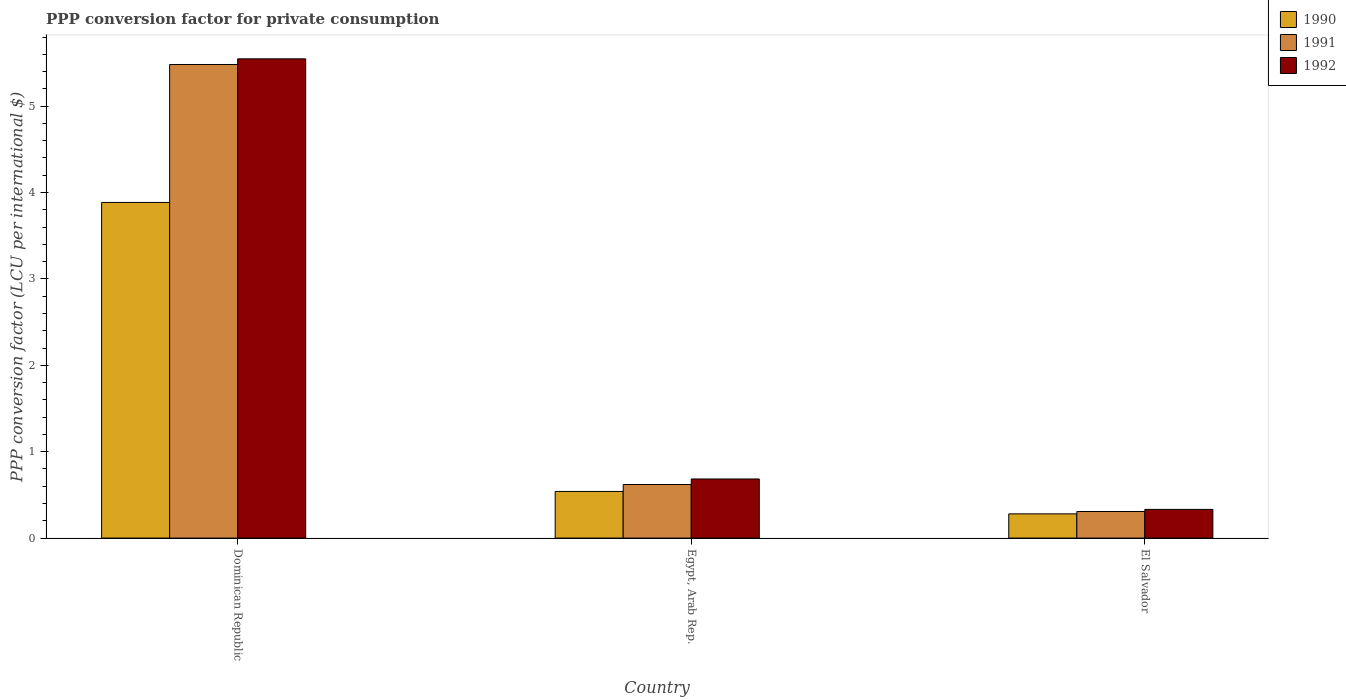How many different coloured bars are there?
Make the answer very short. 3. Are the number of bars on each tick of the X-axis equal?
Ensure brevity in your answer.  Yes. How many bars are there on the 1st tick from the left?
Keep it short and to the point. 3. What is the label of the 1st group of bars from the left?
Give a very brief answer. Dominican Republic. In how many cases, is the number of bars for a given country not equal to the number of legend labels?
Give a very brief answer. 0. What is the PPP conversion factor for private consumption in 1992 in El Salvador?
Offer a very short reply. 0.33. Across all countries, what is the maximum PPP conversion factor for private consumption in 1991?
Make the answer very short. 5.48. Across all countries, what is the minimum PPP conversion factor for private consumption in 1991?
Your answer should be compact. 0.31. In which country was the PPP conversion factor for private consumption in 1990 maximum?
Keep it short and to the point. Dominican Republic. In which country was the PPP conversion factor for private consumption in 1991 minimum?
Provide a succinct answer. El Salvador. What is the total PPP conversion factor for private consumption in 1991 in the graph?
Keep it short and to the point. 6.41. What is the difference between the PPP conversion factor for private consumption in 1991 in Dominican Republic and that in El Salvador?
Provide a succinct answer. 5.17. What is the difference between the PPP conversion factor for private consumption in 1991 in El Salvador and the PPP conversion factor for private consumption in 1992 in Dominican Republic?
Give a very brief answer. -5.24. What is the average PPP conversion factor for private consumption in 1990 per country?
Provide a succinct answer. 1.57. What is the difference between the PPP conversion factor for private consumption of/in 1992 and PPP conversion factor for private consumption of/in 1991 in Egypt, Arab Rep.?
Your answer should be compact. 0.06. In how many countries, is the PPP conversion factor for private consumption in 1992 greater than 3.8 LCU?
Offer a very short reply. 1. What is the ratio of the PPP conversion factor for private consumption in 1990 in Dominican Republic to that in Egypt, Arab Rep.?
Keep it short and to the point. 7.19. What is the difference between the highest and the second highest PPP conversion factor for private consumption in 1992?
Keep it short and to the point. 0.35. What is the difference between the highest and the lowest PPP conversion factor for private consumption in 1990?
Ensure brevity in your answer.  3.6. In how many countries, is the PPP conversion factor for private consumption in 1991 greater than the average PPP conversion factor for private consumption in 1991 taken over all countries?
Make the answer very short. 1. Is the sum of the PPP conversion factor for private consumption in 1992 in Egypt, Arab Rep. and El Salvador greater than the maximum PPP conversion factor for private consumption in 1991 across all countries?
Offer a very short reply. No. What does the 2nd bar from the left in Egypt, Arab Rep. represents?
Your answer should be very brief. 1991. How many bars are there?
Your answer should be very brief. 9. How many countries are there in the graph?
Provide a short and direct response. 3. Are the values on the major ticks of Y-axis written in scientific E-notation?
Make the answer very short. No. Does the graph contain any zero values?
Your answer should be compact. No. Where does the legend appear in the graph?
Make the answer very short. Top right. How many legend labels are there?
Keep it short and to the point. 3. What is the title of the graph?
Your answer should be compact. PPP conversion factor for private consumption. Does "2005" appear as one of the legend labels in the graph?
Your answer should be compact. No. What is the label or title of the X-axis?
Provide a short and direct response. Country. What is the label or title of the Y-axis?
Your answer should be compact. PPP conversion factor (LCU per international $). What is the PPP conversion factor (LCU per international $) in 1990 in Dominican Republic?
Make the answer very short. 3.89. What is the PPP conversion factor (LCU per international $) in 1991 in Dominican Republic?
Provide a succinct answer. 5.48. What is the PPP conversion factor (LCU per international $) of 1992 in Dominican Republic?
Your answer should be compact. 5.55. What is the PPP conversion factor (LCU per international $) in 1990 in Egypt, Arab Rep.?
Your response must be concise. 0.54. What is the PPP conversion factor (LCU per international $) of 1991 in Egypt, Arab Rep.?
Ensure brevity in your answer.  0.62. What is the PPP conversion factor (LCU per international $) of 1992 in Egypt, Arab Rep.?
Make the answer very short. 0.68. What is the PPP conversion factor (LCU per international $) of 1990 in El Salvador?
Make the answer very short. 0.28. What is the PPP conversion factor (LCU per international $) of 1991 in El Salvador?
Your answer should be very brief. 0.31. What is the PPP conversion factor (LCU per international $) of 1992 in El Salvador?
Provide a short and direct response. 0.33. Across all countries, what is the maximum PPP conversion factor (LCU per international $) of 1990?
Offer a very short reply. 3.89. Across all countries, what is the maximum PPP conversion factor (LCU per international $) of 1991?
Give a very brief answer. 5.48. Across all countries, what is the maximum PPP conversion factor (LCU per international $) in 1992?
Keep it short and to the point. 5.55. Across all countries, what is the minimum PPP conversion factor (LCU per international $) in 1990?
Ensure brevity in your answer.  0.28. Across all countries, what is the minimum PPP conversion factor (LCU per international $) of 1991?
Provide a succinct answer. 0.31. Across all countries, what is the minimum PPP conversion factor (LCU per international $) in 1992?
Make the answer very short. 0.33. What is the total PPP conversion factor (LCU per international $) in 1990 in the graph?
Give a very brief answer. 4.71. What is the total PPP conversion factor (LCU per international $) of 1991 in the graph?
Your answer should be very brief. 6.41. What is the total PPP conversion factor (LCU per international $) in 1992 in the graph?
Offer a terse response. 6.56. What is the difference between the PPP conversion factor (LCU per international $) of 1990 in Dominican Republic and that in Egypt, Arab Rep.?
Ensure brevity in your answer.  3.35. What is the difference between the PPP conversion factor (LCU per international $) in 1991 in Dominican Republic and that in Egypt, Arab Rep.?
Provide a succinct answer. 4.86. What is the difference between the PPP conversion factor (LCU per international $) in 1992 in Dominican Republic and that in Egypt, Arab Rep.?
Provide a succinct answer. 4.86. What is the difference between the PPP conversion factor (LCU per international $) of 1990 in Dominican Republic and that in El Salvador?
Make the answer very short. 3.6. What is the difference between the PPP conversion factor (LCU per international $) in 1991 in Dominican Republic and that in El Salvador?
Give a very brief answer. 5.17. What is the difference between the PPP conversion factor (LCU per international $) in 1992 in Dominican Republic and that in El Salvador?
Offer a terse response. 5.22. What is the difference between the PPP conversion factor (LCU per international $) of 1990 in Egypt, Arab Rep. and that in El Salvador?
Your answer should be very brief. 0.26. What is the difference between the PPP conversion factor (LCU per international $) in 1991 in Egypt, Arab Rep. and that in El Salvador?
Provide a short and direct response. 0.31. What is the difference between the PPP conversion factor (LCU per international $) of 1992 in Egypt, Arab Rep. and that in El Salvador?
Offer a very short reply. 0.35. What is the difference between the PPP conversion factor (LCU per international $) of 1990 in Dominican Republic and the PPP conversion factor (LCU per international $) of 1991 in Egypt, Arab Rep.?
Provide a succinct answer. 3.26. What is the difference between the PPP conversion factor (LCU per international $) of 1990 in Dominican Republic and the PPP conversion factor (LCU per international $) of 1992 in Egypt, Arab Rep.?
Ensure brevity in your answer.  3.2. What is the difference between the PPP conversion factor (LCU per international $) in 1991 in Dominican Republic and the PPP conversion factor (LCU per international $) in 1992 in Egypt, Arab Rep.?
Offer a very short reply. 4.8. What is the difference between the PPP conversion factor (LCU per international $) of 1990 in Dominican Republic and the PPP conversion factor (LCU per international $) of 1991 in El Salvador?
Ensure brevity in your answer.  3.58. What is the difference between the PPP conversion factor (LCU per international $) of 1990 in Dominican Republic and the PPP conversion factor (LCU per international $) of 1992 in El Salvador?
Your answer should be very brief. 3.55. What is the difference between the PPP conversion factor (LCU per international $) of 1991 in Dominican Republic and the PPP conversion factor (LCU per international $) of 1992 in El Salvador?
Your answer should be compact. 5.15. What is the difference between the PPP conversion factor (LCU per international $) of 1990 in Egypt, Arab Rep. and the PPP conversion factor (LCU per international $) of 1991 in El Salvador?
Your response must be concise. 0.23. What is the difference between the PPP conversion factor (LCU per international $) of 1990 in Egypt, Arab Rep. and the PPP conversion factor (LCU per international $) of 1992 in El Salvador?
Provide a short and direct response. 0.21. What is the difference between the PPP conversion factor (LCU per international $) in 1991 in Egypt, Arab Rep. and the PPP conversion factor (LCU per international $) in 1992 in El Salvador?
Offer a terse response. 0.29. What is the average PPP conversion factor (LCU per international $) in 1990 per country?
Your answer should be very brief. 1.57. What is the average PPP conversion factor (LCU per international $) of 1991 per country?
Your answer should be compact. 2.14. What is the average PPP conversion factor (LCU per international $) of 1992 per country?
Your response must be concise. 2.19. What is the difference between the PPP conversion factor (LCU per international $) in 1990 and PPP conversion factor (LCU per international $) in 1991 in Dominican Republic?
Your response must be concise. -1.6. What is the difference between the PPP conversion factor (LCU per international $) in 1990 and PPP conversion factor (LCU per international $) in 1992 in Dominican Republic?
Your response must be concise. -1.66. What is the difference between the PPP conversion factor (LCU per international $) of 1991 and PPP conversion factor (LCU per international $) of 1992 in Dominican Republic?
Keep it short and to the point. -0.07. What is the difference between the PPP conversion factor (LCU per international $) of 1990 and PPP conversion factor (LCU per international $) of 1991 in Egypt, Arab Rep.?
Your answer should be very brief. -0.08. What is the difference between the PPP conversion factor (LCU per international $) in 1990 and PPP conversion factor (LCU per international $) in 1992 in Egypt, Arab Rep.?
Make the answer very short. -0.14. What is the difference between the PPP conversion factor (LCU per international $) in 1991 and PPP conversion factor (LCU per international $) in 1992 in Egypt, Arab Rep.?
Offer a terse response. -0.06. What is the difference between the PPP conversion factor (LCU per international $) of 1990 and PPP conversion factor (LCU per international $) of 1991 in El Salvador?
Your response must be concise. -0.03. What is the difference between the PPP conversion factor (LCU per international $) of 1990 and PPP conversion factor (LCU per international $) of 1992 in El Salvador?
Provide a short and direct response. -0.05. What is the difference between the PPP conversion factor (LCU per international $) of 1991 and PPP conversion factor (LCU per international $) of 1992 in El Salvador?
Keep it short and to the point. -0.02. What is the ratio of the PPP conversion factor (LCU per international $) in 1990 in Dominican Republic to that in Egypt, Arab Rep.?
Your answer should be very brief. 7.19. What is the ratio of the PPP conversion factor (LCU per international $) in 1991 in Dominican Republic to that in Egypt, Arab Rep.?
Your answer should be compact. 8.84. What is the ratio of the PPP conversion factor (LCU per international $) of 1992 in Dominican Republic to that in Egypt, Arab Rep.?
Your answer should be very brief. 8.11. What is the ratio of the PPP conversion factor (LCU per international $) in 1990 in Dominican Republic to that in El Salvador?
Provide a succinct answer. 13.86. What is the ratio of the PPP conversion factor (LCU per international $) of 1991 in Dominican Republic to that in El Salvador?
Your response must be concise. 17.81. What is the ratio of the PPP conversion factor (LCU per international $) in 1992 in Dominican Republic to that in El Salvador?
Ensure brevity in your answer.  16.7. What is the ratio of the PPP conversion factor (LCU per international $) in 1990 in Egypt, Arab Rep. to that in El Salvador?
Provide a short and direct response. 1.93. What is the ratio of the PPP conversion factor (LCU per international $) in 1991 in Egypt, Arab Rep. to that in El Salvador?
Provide a short and direct response. 2.02. What is the ratio of the PPP conversion factor (LCU per international $) in 1992 in Egypt, Arab Rep. to that in El Salvador?
Offer a terse response. 2.06. What is the difference between the highest and the second highest PPP conversion factor (LCU per international $) in 1990?
Your answer should be compact. 3.35. What is the difference between the highest and the second highest PPP conversion factor (LCU per international $) of 1991?
Your response must be concise. 4.86. What is the difference between the highest and the second highest PPP conversion factor (LCU per international $) in 1992?
Your answer should be very brief. 4.86. What is the difference between the highest and the lowest PPP conversion factor (LCU per international $) of 1990?
Your answer should be very brief. 3.6. What is the difference between the highest and the lowest PPP conversion factor (LCU per international $) in 1991?
Your response must be concise. 5.17. What is the difference between the highest and the lowest PPP conversion factor (LCU per international $) of 1992?
Provide a short and direct response. 5.22. 